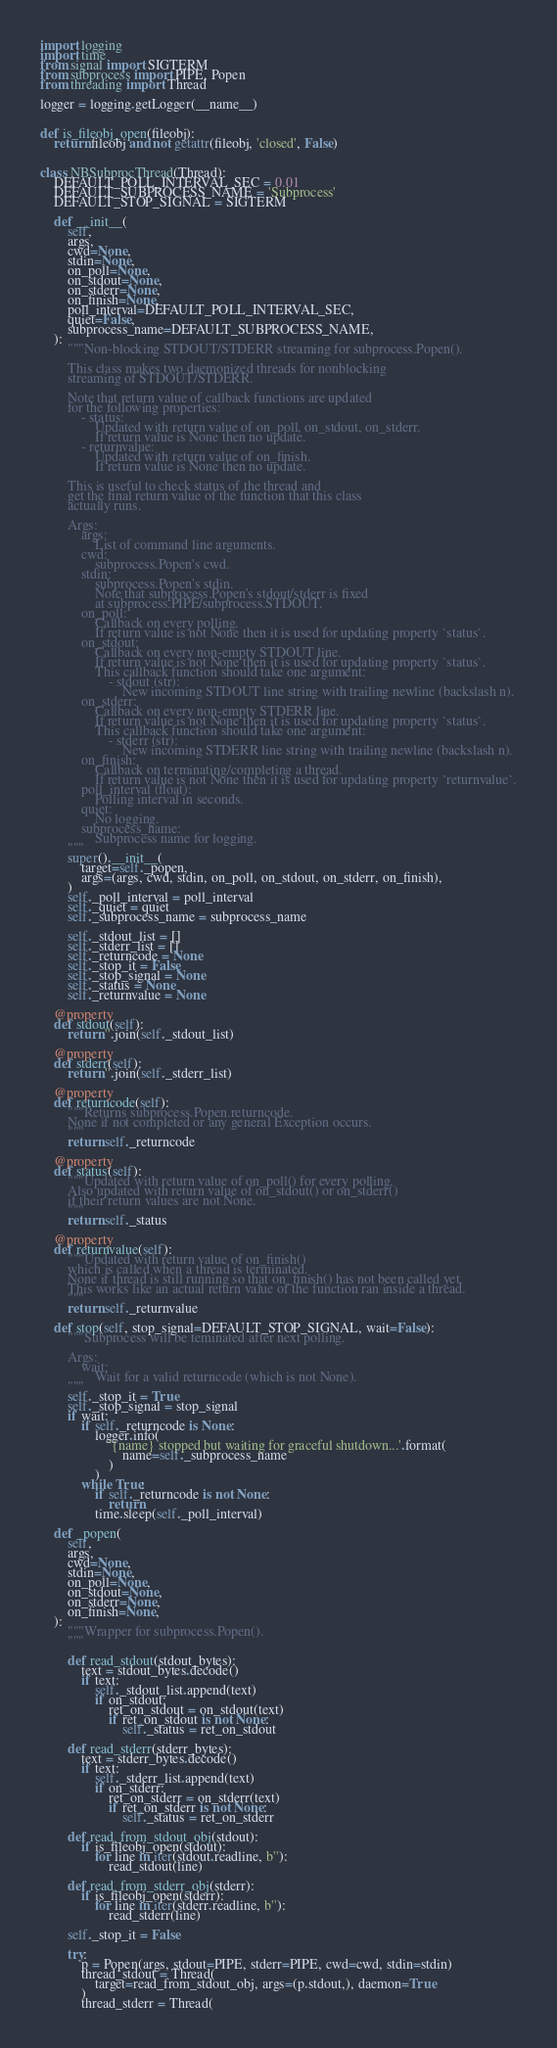Convert code to text. <code><loc_0><loc_0><loc_500><loc_500><_Python_>import logging
import time
from signal import SIGTERM
from subprocess import PIPE, Popen
from threading import Thread

logger = logging.getLogger(__name__)


def is_fileobj_open(fileobj):
    return fileobj and not getattr(fileobj, 'closed', False)


class NBSubprocThread(Thread):
    DEFAULT_POLL_INTERVAL_SEC = 0.01
    DEFAULT_SUBPROCESS_NAME = 'Subprocess'
    DEFAULT_STOP_SIGNAL = SIGTERM

    def __init__(
        self,
        args,
        cwd=None,
        stdin=None,
        on_poll=None,
        on_stdout=None,
        on_stderr=None,
        on_finish=None,
        poll_interval=DEFAULT_POLL_INTERVAL_SEC,
        quiet=False,
        subprocess_name=DEFAULT_SUBPROCESS_NAME,
    ):
        """Non-blocking STDOUT/STDERR streaming for subprocess.Popen().

        This class makes two daemonized threads for nonblocking
        streaming of STDOUT/STDERR.

        Note that return value of callback functions are updated
        for the following properties:
            - status:
                Updated with return value of on_poll, on_stdout, on_stderr.
                If return value is None then no update.
            - returnvalue:
                Updated with return value of on_finish.
                If return value is None then no update.

        This is useful to check status of the thread and
        get the final return value of the function that this class
        actually runs.

        Args:
            args:
                List of command line arguments.
            cwd:
                subprocess.Popen's cwd.
            stdin:
                subprocess.Popen's stdin.
                Note that subprocess.Popen's stdout/stderr is fixed
                at subprocess.PIPE/subprocess.STDOUT.
            on_poll:
                Callback on every polling.
                If return value is not None then it is used for updating property `status`.
            on_stdout:
                Callback on every non-empty STDOUT line.
                If return value is not None then it is used for updating property `status`.
                This callback function should take one argument:
                    - stdout (str):
                        New incoming STDOUT line string with trailing newline (backslash n).
            on_stderr:
                Callback on every non-empty STDERR line.
                If return value is not None then it is used for updating property `status`.
                This callback function should take one argument:
                    - stderr (str):
                        New incoming STDERR line string with trailing newline (backslash n).
            on_finish:
                Callback on terminating/completing a thread.
                If return value is not None then it is used for updating property `returnvalue`.
            poll_interval (float):
                Polling interval in seconds.
            quiet:
                No logging.
            subprocess_name:
                Subprocess name for logging.
        """
        super().__init__(
            target=self._popen,
            args=(args, cwd, stdin, on_poll, on_stdout, on_stderr, on_finish),
        )
        self._poll_interval = poll_interval
        self._quiet = quiet
        self._subprocess_name = subprocess_name

        self._stdout_list = []
        self._stderr_list = []
        self._returncode = None
        self._stop_it = False
        self._stop_signal = None
        self._status = None
        self._returnvalue = None

    @property
    def stdout(self):
        return ''.join(self._stdout_list)

    @property
    def stderr(self):
        return ''.join(self._stderr_list)

    @property
    def returncode(self):
        """Returns subprocess.Popen.returncode.
        None if not completed or any general Exception occurs.
        """
        return self._returncode

    @property
    def status(self):
        """Updated with return value of on_poll() for every polling.
        Also updated with return value of on_stdout() or on_stderr()
        if their return values are not None.
        """
        return self._status

    @property
    def returnvalue(self):
        """Updated with return value of on_finish()
        which is called when a thread is terminated.
        None if thread is still running so that on_finish() has not been called yet.
        This works like an actual return value of the function ran inside a thread.
        """
        return self._returnvalue

    def stop(self, stop_signal=DEFAULT_STOP_SIGNAL, wait=False):
        """Subprocess will be teminated after next polling.

        Args:
            wait:
                Wait for a valid returncode (which is not None).
        """
        self._stop_it = True
        self._stop_signal = stop_signal
        if wait:
            if self._returncode is None:
                logger.info(
                    '{name} stopped but waiting for graceful shutdown...'.format(
                        name=self._subprocess_name
                    )
                )
            while True:
                if self._returncode is not None:
                    return
                time.sleep(self._poll_interval)

    def _popen(
        self,
        args,
        cwd=None,
        stdin=None,
        on_poll=None,
        on_stdout=None,
        on_stderr=None,
        on_finish=None,
    ):
        """Wrapper for subprocess.Popen().
        """

        def read_stdout(stdout_bytes):
            text = stdout_bytes.decode()
            if text:
                self._stdout_list.append(text)
                if on_stdout:
                    ret_on_stdout = on_stdout(text)
                    if ret_on_stdout is not None:
                        self._status = ret_on_stdout

        def read_stderr(stderr_bytes):
            text = stderr_bytes.decode()
            if text:
                self._stderr_list.append(text)
                if on_stderr:
                    ret_on_stderr = on_stderr(text)
                    if ret_on_stderr is not None:
                        self._status = ret_on_stderr

        def read_from_stdout_obj(stdout):
            if is_fileobj_open(stdout):
                for line in iter(stdout.readline, b''):
                    read_stdout(line)

        def read_from_stderr_obj(stderr):
            if is_fileobj_open(stderr):
                for line in iter(stderr.readline, b''):
                    read_stderr(line)

        self._stop_it = False

        try:
            p = Popen(args, stdout=PIPE, stderr=PIPE, cwd=cwd, stdin=stdin)
            thread_stdout = Thread(
                target=read_from_stdout_obj, args=(p.stdout,), daemon=True
            )
            thread_stderr = Thread(</code> 